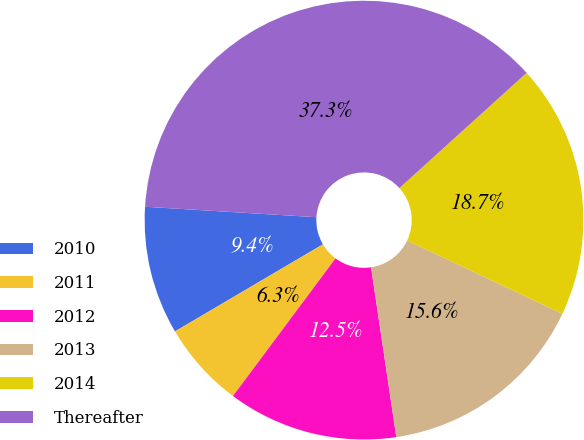<chart> <loc_0><loc_0><loc_500><loc_500><pie_chart><fcel>2010<fcel>2011<fcel>2012<fcel>2013<fcel>2014<fcel>Thereafter<nl><fcel>9.44%<fcel>6.34%<fcel>12.54%<fcel>15.63%<fcel>18.73%<fcel>37.31%<nl></chart> 